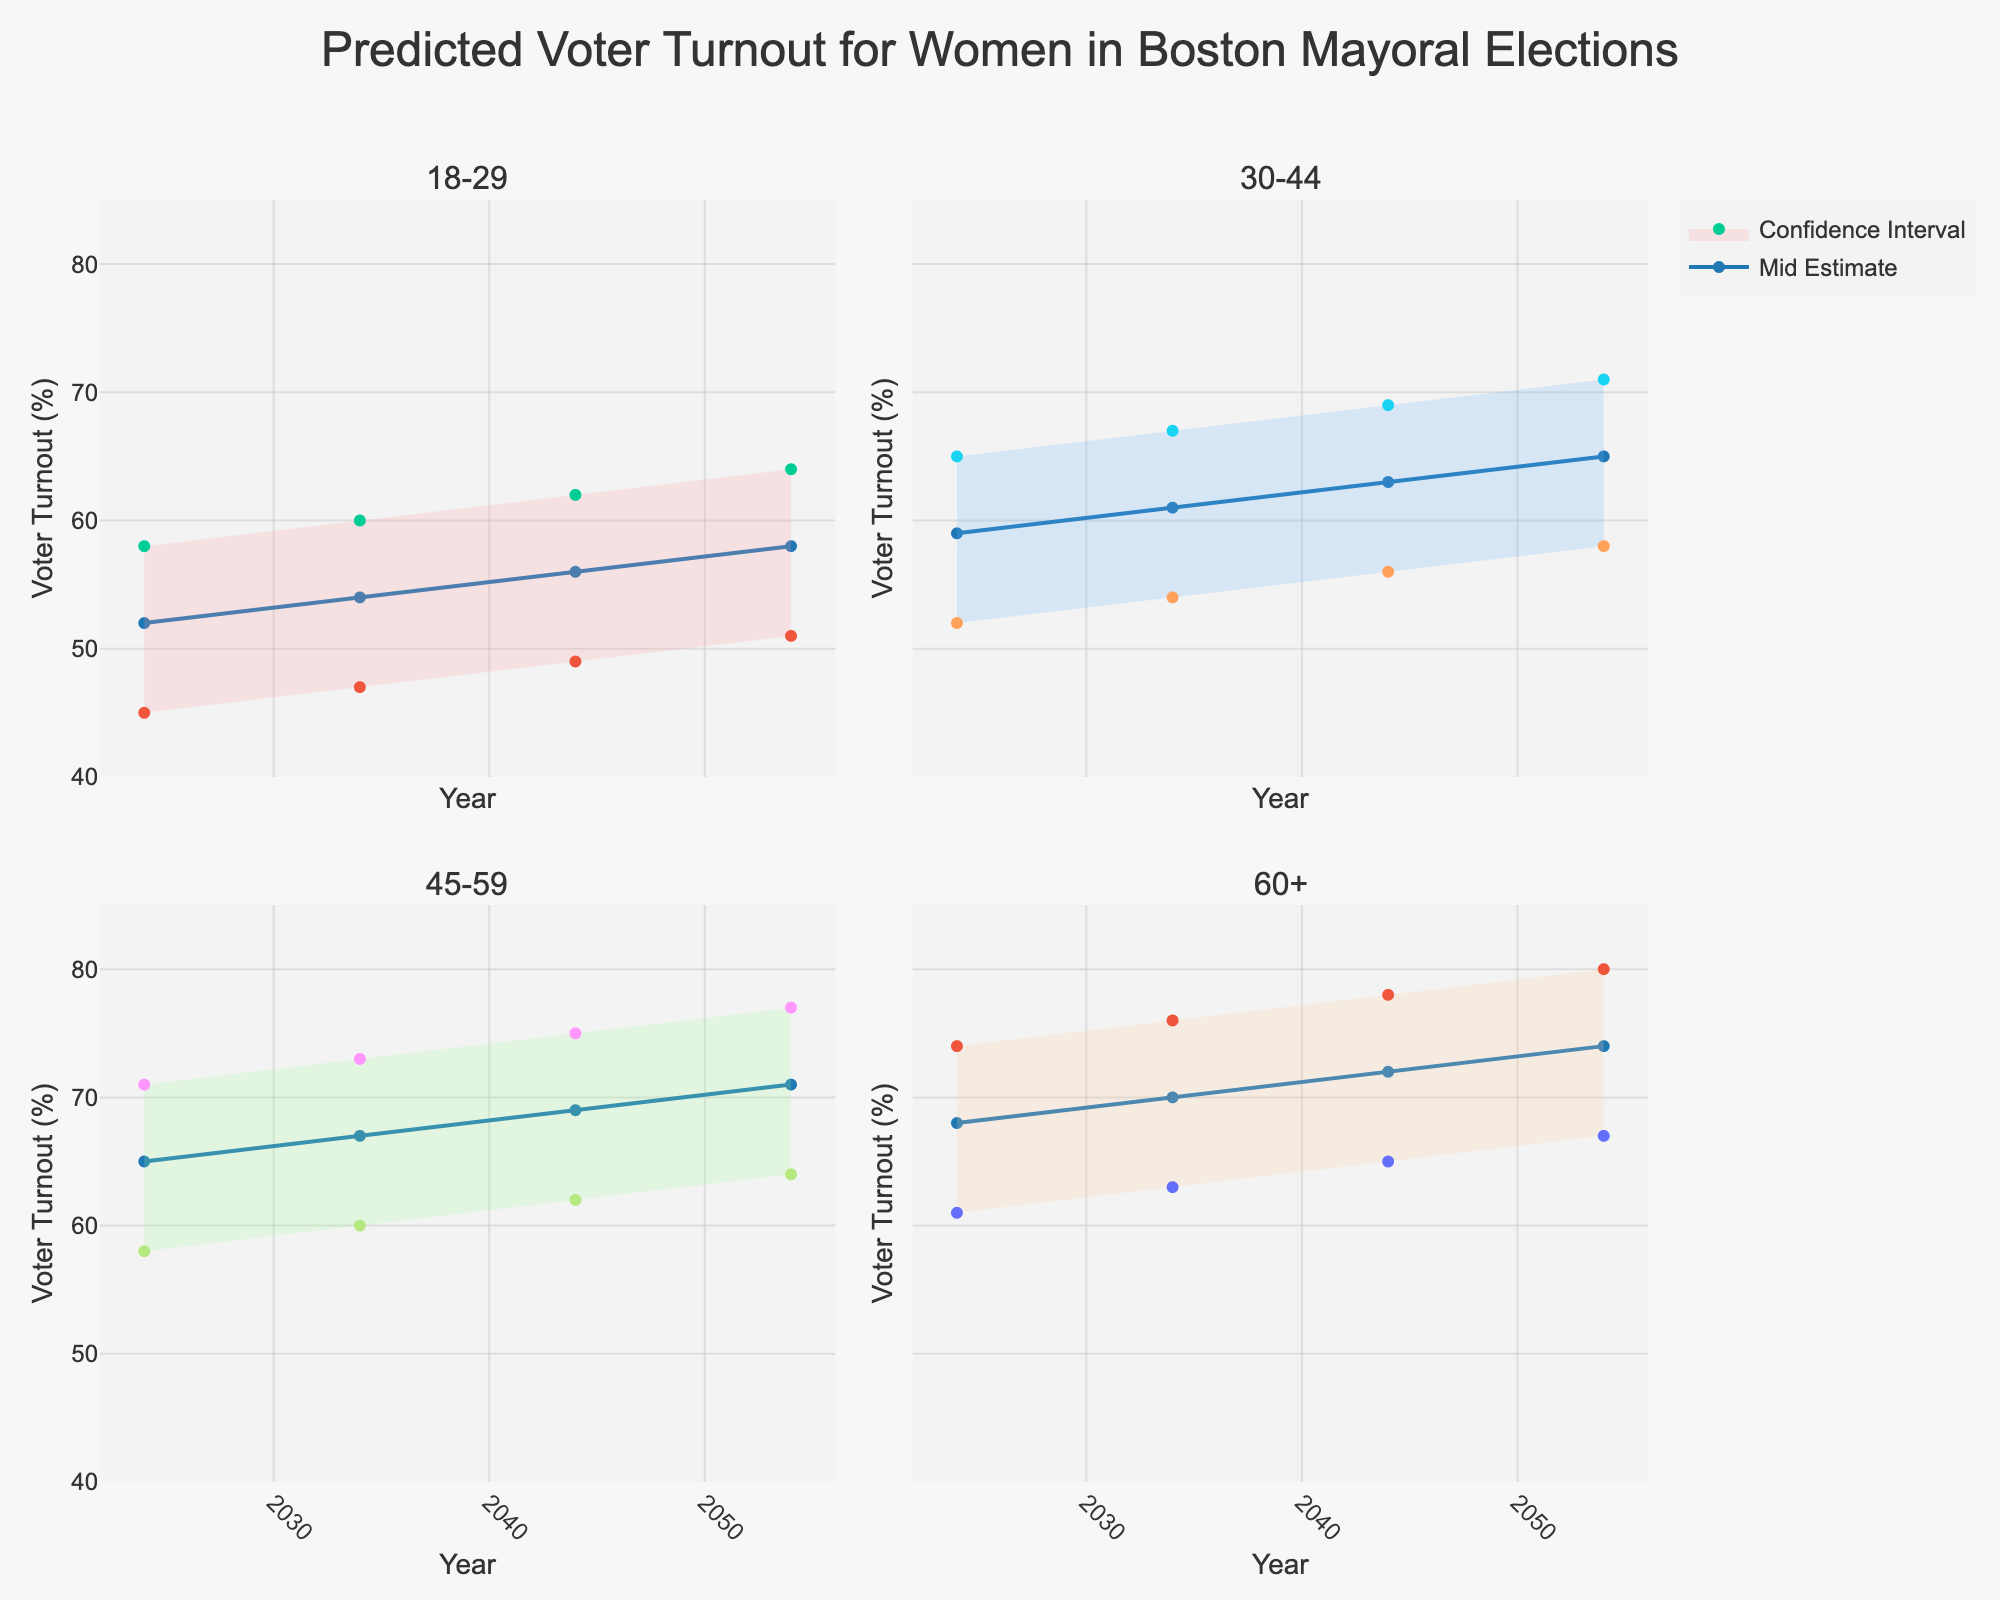What is the highest predicted voter turnout for the age group 60+ in 2054? The highest predicted voter turnout for the age group 60+ in 2054 can be found from the "High Estimate" value in the corresponding subplot. This value is 80%.
Answer: 80% Which age group is predicted to have the lowest voter turnout in 2024 according to the mid estimate? To find the age group with the lowest mid estimate in 2024, compare the mid estimate values for all age groups. The values for 2024 are: 52% (18-29), 59% (30-44), 65% (45-59), and 68% (60+). The age group 18-29 has the lowest mid estimate of 52%.
Answer: 18-29 By how many percentage points does the mid estimate for the 18-29 age group increase from 2024 to 2054? To find the increase, subtract the mid estimate for 2024 from the mid estimate for 2054 for the 18-29 age group. This is 58% - 52% = 6%.
Answer: 6% How does the confidence interval range for the 45-59 age group in 2044 compare to the same age group in 2034? To compare the ranges, subtract the low estimate from the high estimate for each year. For 2044: 75% - 62% = 13%. For 2034: 73% - 60% = 13%. The ranges are equal.
Answer: Equal What is the trend of the mid estimate for the 30-44 age group over the years from 2024 to 2054? To identify the trend, observe the mid estimate values for the 30-44 age group over the years: 59% in 2024, 61% in 2034, 63% in 2044, and 65% in 2054. The trend shows a gradual increase.
Answer: Gradual increase Which age group shows the smallest difference between the mid estimate and the high estimate in 2034? To determine the smallest difference, subtract the mid estimate from the high estimate for each age group in 2034. Differences are: 6% (18-29), 6% (30-44), 6% (45-59), 6% (60+). All age groups have the same difference of 6%.
Answer: All age groups Which year shows the largest mid estimate for the 60+ age group? To find this, compare the mid estimate values for the 60+ age group across the years: 68% in 2024, 70% in 2034, 72% in 2044, and 74% in 2054. The largest mid estimate is in 2054.
Answer: 2054 What is the difference between the low estimate and the high estimate for the 18-29 age group in 2044? To find the difference, subtract the low estimate from the high estimate for the 18-29 age group in 2044. This is 62% - 49% = 13%.
Answer: 13% 